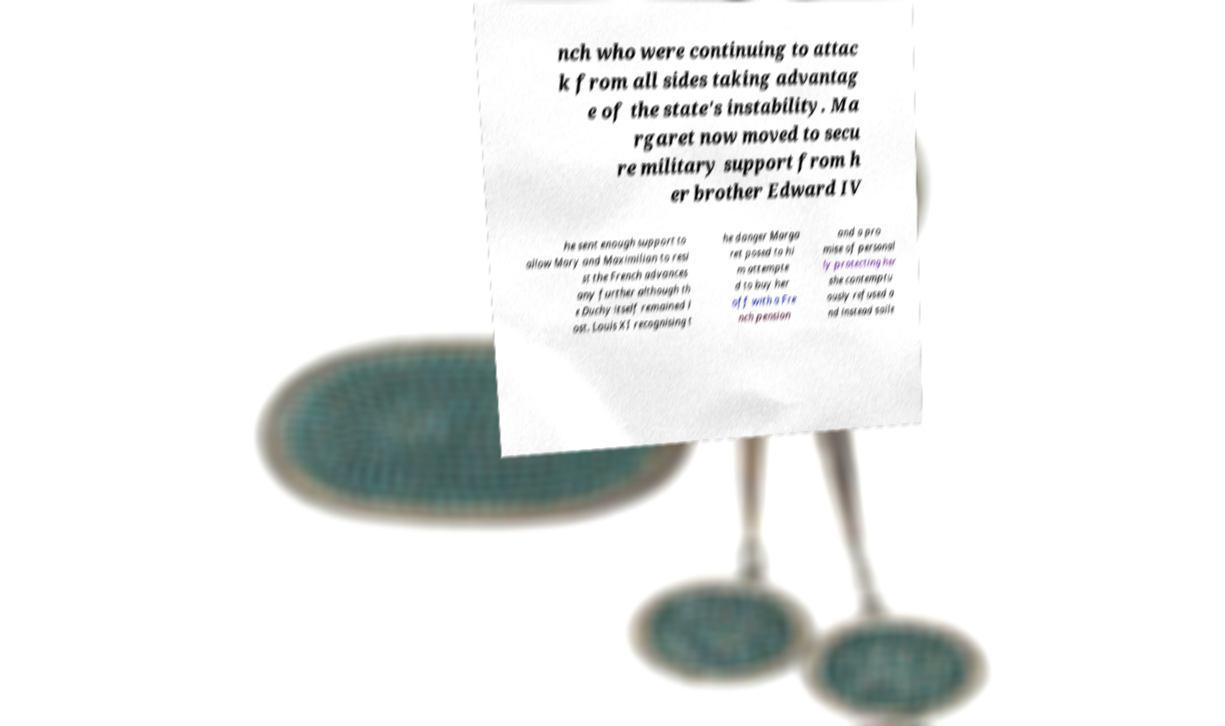Please identify and transcribe the text found in this image. nch who were continuing to attac k from all sides taking advantag e of the state's instability. Ma rgaret now moved to secu re military support from h er brother Edward IV he sent enough support to allow Mary and Maximilian to resi st the French advances any further although th e Duchy itself remained l ost. Louis XI recognising t he danger Marga ret posed to hi m attempte d to buy her off with a Fre nch pension and a pro mise of personal ly protecting her she contemptu ously refused a nd instead saile 